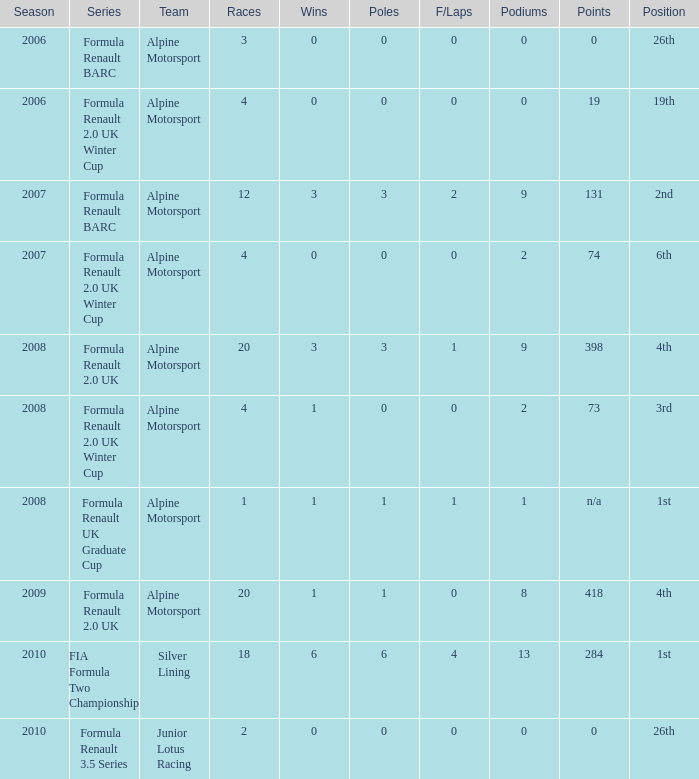Would you be able to parse every entry in this table? {'header': ['Season', 'Series', 'Team', 'Races', 'Wins', 'Poles', 'F/Laps', 'Podiums', 'Points', 'Position'], 'rows': [['2006', 'Formula Renault BARC', 'Alpine Motorsport', '3', '0', '0', '0', '0', '0', '26th'], ['2006', 'Formula Renault 2.0 UK Winter Cup', 'Alpine Motorsport', '4', '0', '0', '0', '0', '19', '19th'], ['2007', 'Formula Renault BARC', 'Alpine Motorsport', '12', '3', '3', '2', '9', '131', '2nd'], ['2007', 'Formula Renault 2.0 UK Winter Cup', 'Alpine Motorsport', '4', '0', '0', '0', '2', '74', '6th'], ['2008', 'Formula Renault 2.0 UK', 'Alpine Motorsport', '20', '3', '3', '1', '9', '398', '4th'], ['2008', 'Formula Renault 2.0 UK Winter Cup', 'Alpine Motorsport', '4', '1', '0', '0', '2', '73', '3rd'], ['2008', 'Formula Renault UK Graduate Cup', 'Alpine Motorsport', '1', '1', '1', '1', '1', 'n/a', '1st'], ['2009', 'Formula Renault 2.0 UK', 'Alpine Motorsport', '20', '1', '1', '0', '8', '418', '4th'], ['2010', 'FIA Formula Two Championship', 'Silver Lining', '18', '6', '6', '4', '13', '284', '1st'], ['2010', 'Formula Renault 3.5 Series', 'Junior Lotus Racing', '2', '0', '0', '0', '0', '0', '26th']]} During which earliest season did the podium reach a total of 9? 2007.0. 